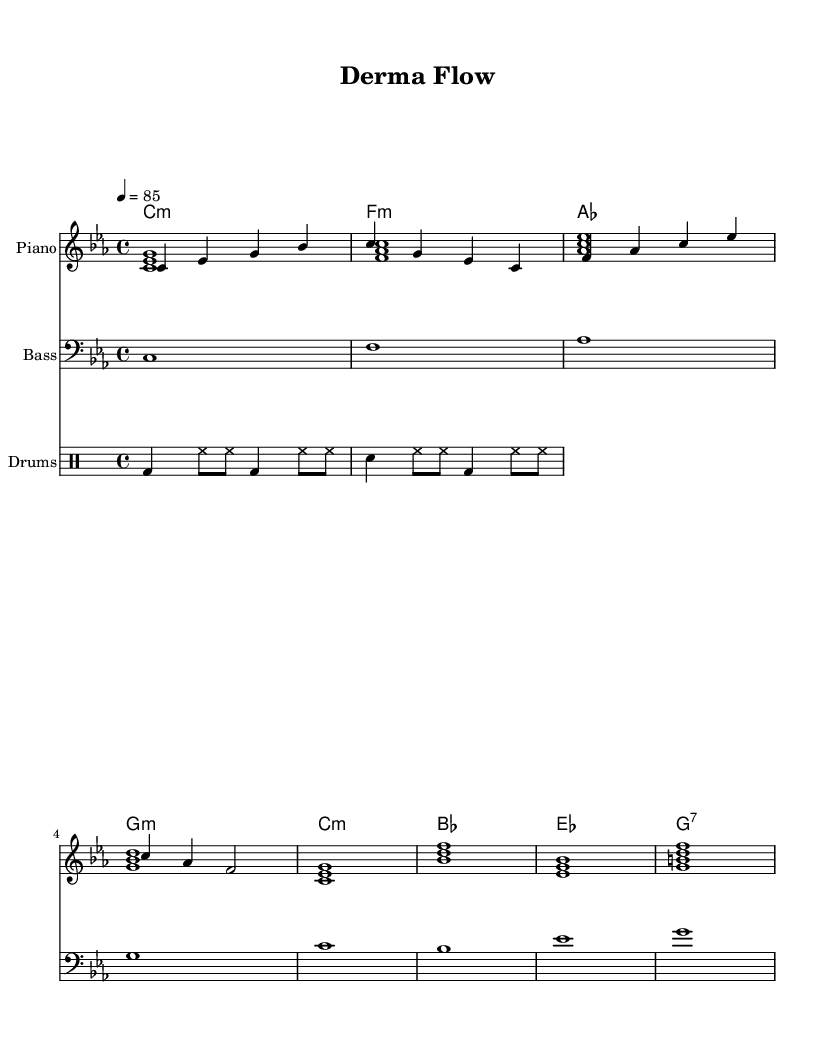What is the key signature of this music? The key signature is C minor, which has three flat notes: B flat, E flat, and A flat. We can determine the key signature by looking at the clef and the accidentals in the measure.
Answer: C minor What is the time signature of this music? The time signature is 4/4, which means there are four beats in a measure, and the quarter note gets one beat. This is indicated at the beginning of the score.
Answer: 4/4 What is the tempo of this music? The tempo is set at 85 beats per minute, as stated in the tempo marking. This indicates how fast the piece should be played.
Answer: 85 How many measures are in the melody section? The melody section has four measures, which can be seen by counting the groups of vertical lines separating the different sections in the staff.
Answer: 4 What is the first chord in the chord progression? The first chord in the progression is C minor, which is indicated at the beginning of the chord names. This chord is the starting point of the progression.
Answer: C minor Which style is this music intended for? This music is intended for instrumental hip-hop beats, which is characterized by its relaxed groove and rhythmic elements perfect for concentration. The overall structure and instrumentation suggest this style.
Answer: Instrumental hip-hop 